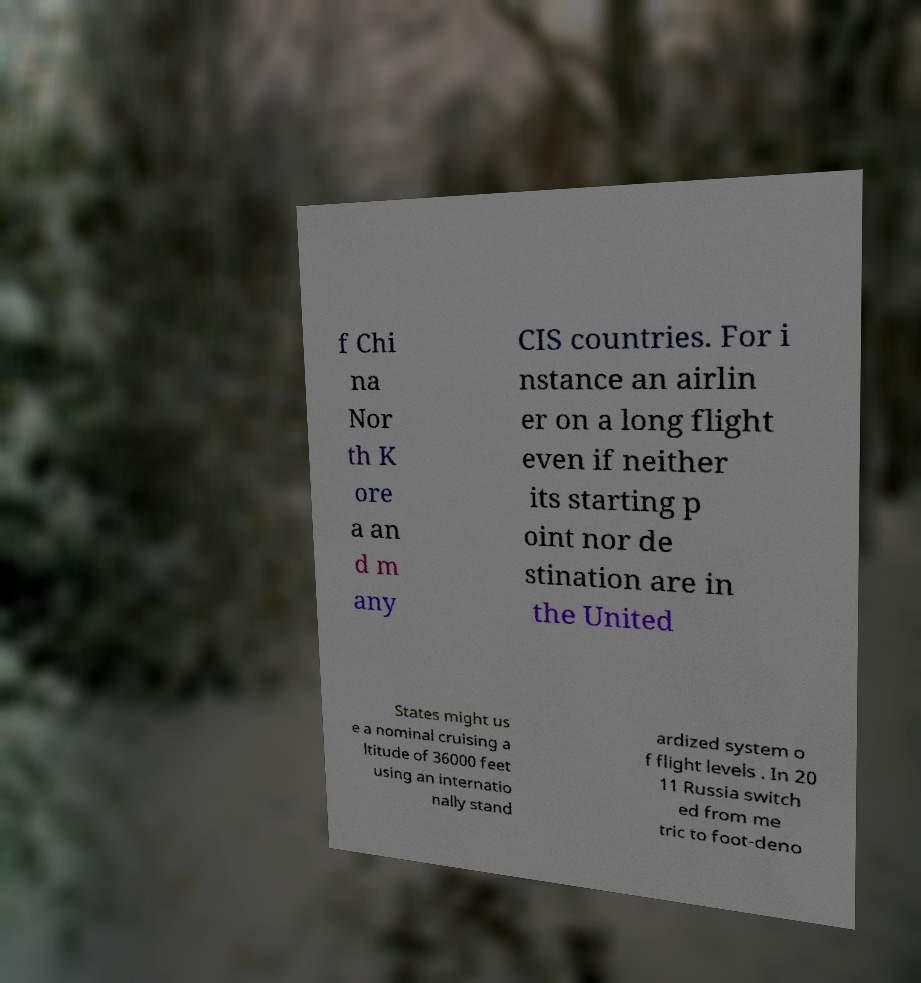Can you accurately transcribe the text from the provided image for me? f Chi na Nor th K ore a an d m any CIS countries. For i nstance an airlin er on a long flight even if neither its starting p oint nor de stination are in the United States might us e a nominal cruising a ltitude of 36000 feet using an internatio nally stand ardized system o f flight levels . In 20 11 Russia switch ed from me tric to foot-deno 